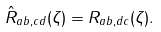<formula> <loc_0><loc_0><loc_500><loc_500>\hat { R } _ { a b , c d } ( \zeta ) = R _ { a b , d c } ( \zeta ) .</formula> 